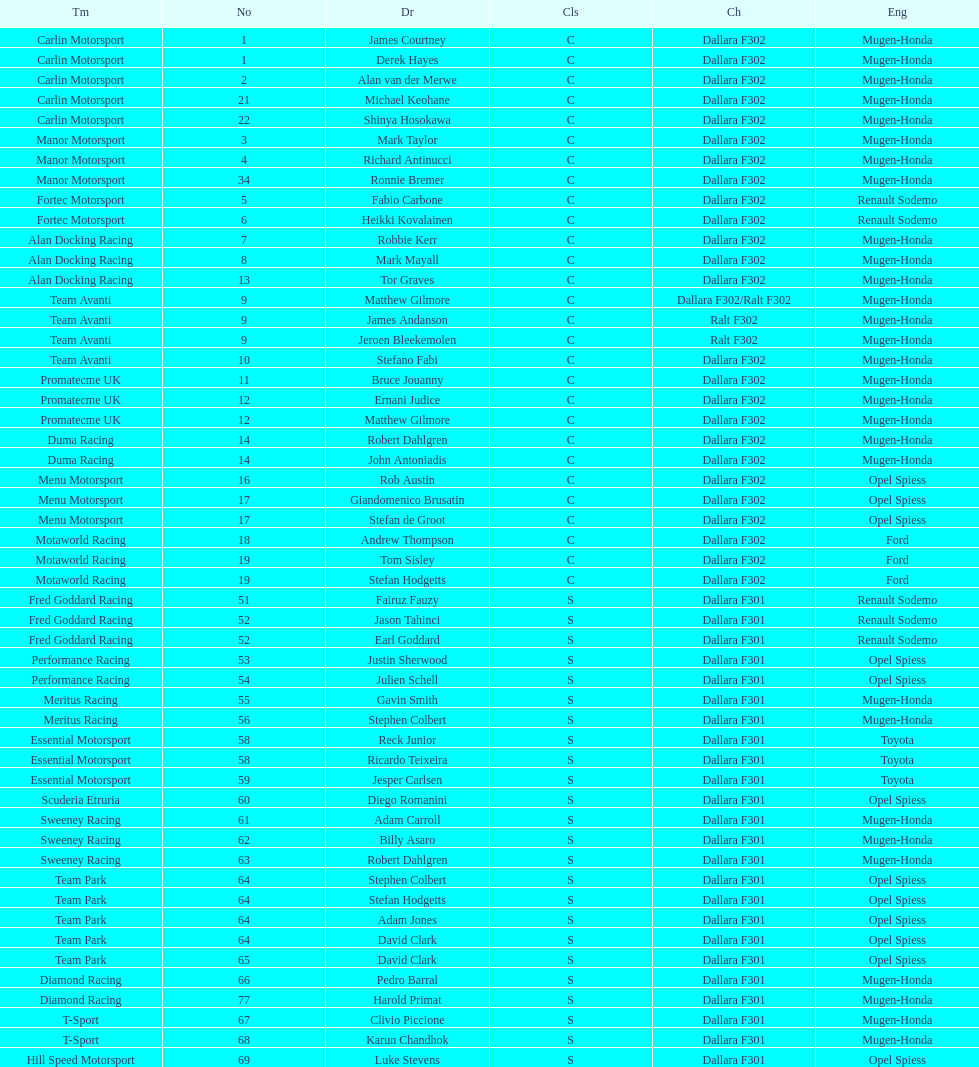How many teams had at least two drivers this season? 17. 